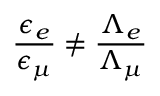<formula> <loc_0><loc_0><loc_500><loc_500>\frac { \epsilon _ { e } } { \epsilon _ { \mu } } \not = \frac { \Lambda _ { e } } { \Lambda _ { \mu } }</formula> 